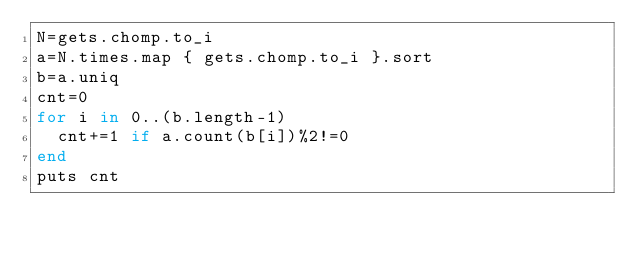Convert code to text. <code><loc_0><loc_0><loc_500><loc_500><_Ruby_>N=gets.chomp.to_i
a=N.times.map { gets.chomp.to_i }.sort
b=a.uniq
cnt=0
for i in 0..(b.length-1)
  cnt+=1 if a.count(b[i])%2!=0
end
puts cnt
</code> 